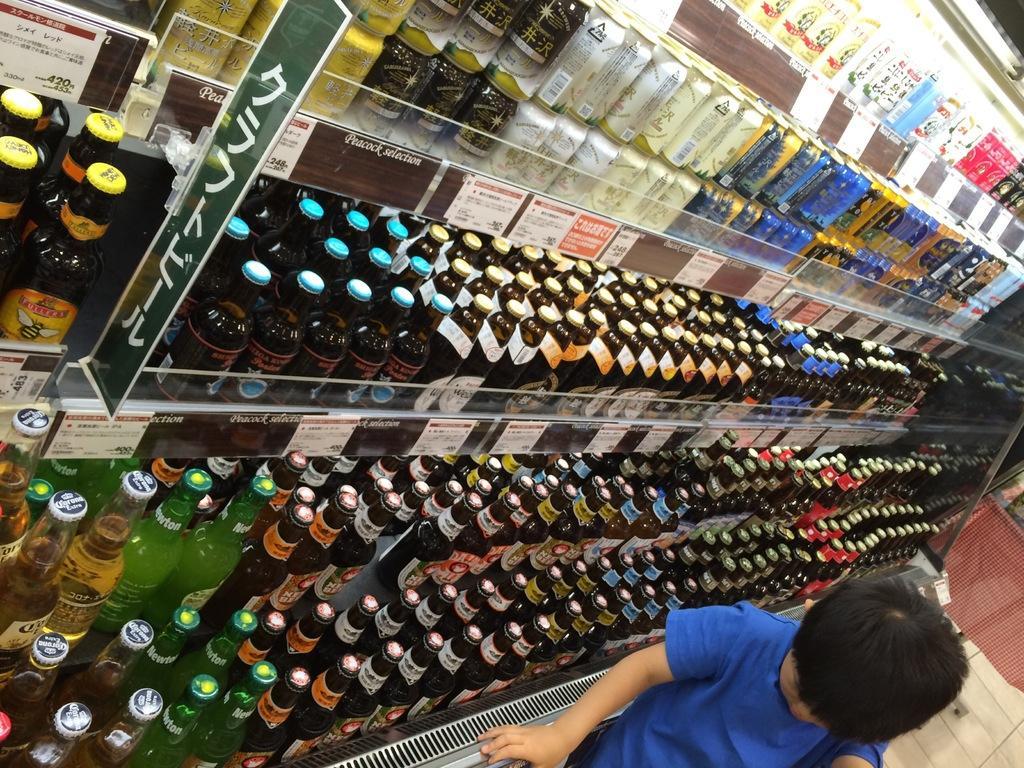In one or two sentences, can you explain what this image depicts? In this image we can see the person standing on the floor. At the back there is the cloth and there are racks, in that there are different types of bottles and stickers attached to the racks. 